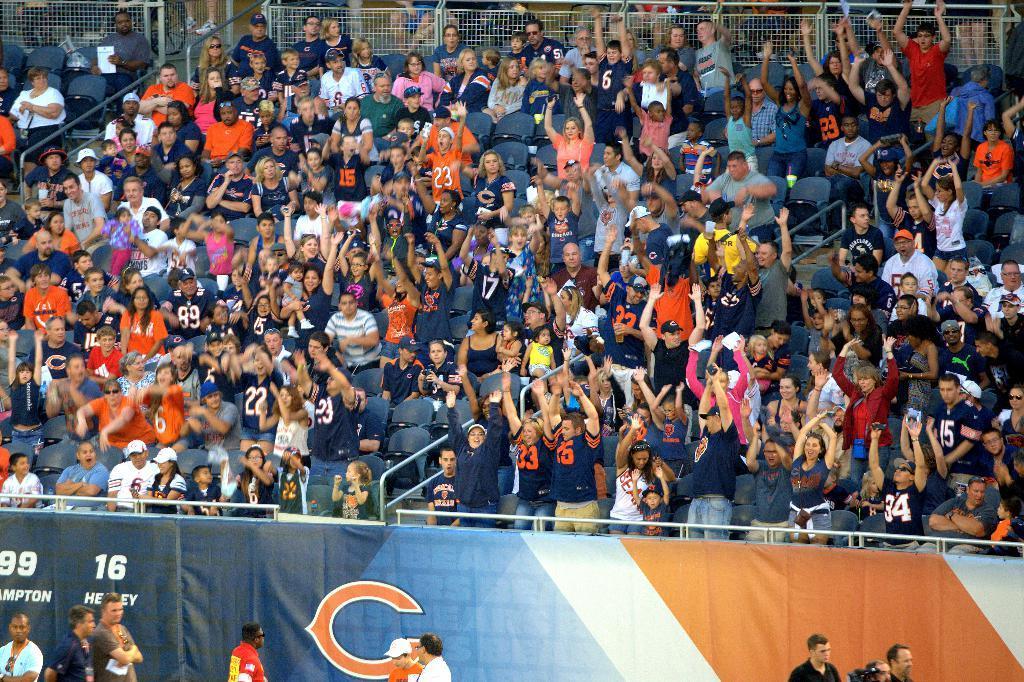Describe this image in one or two sentences. I can see groups of people sitting on the chairs and few people standing. These are the kinds of barricades. This is the hoarding. This looks like a fence. 